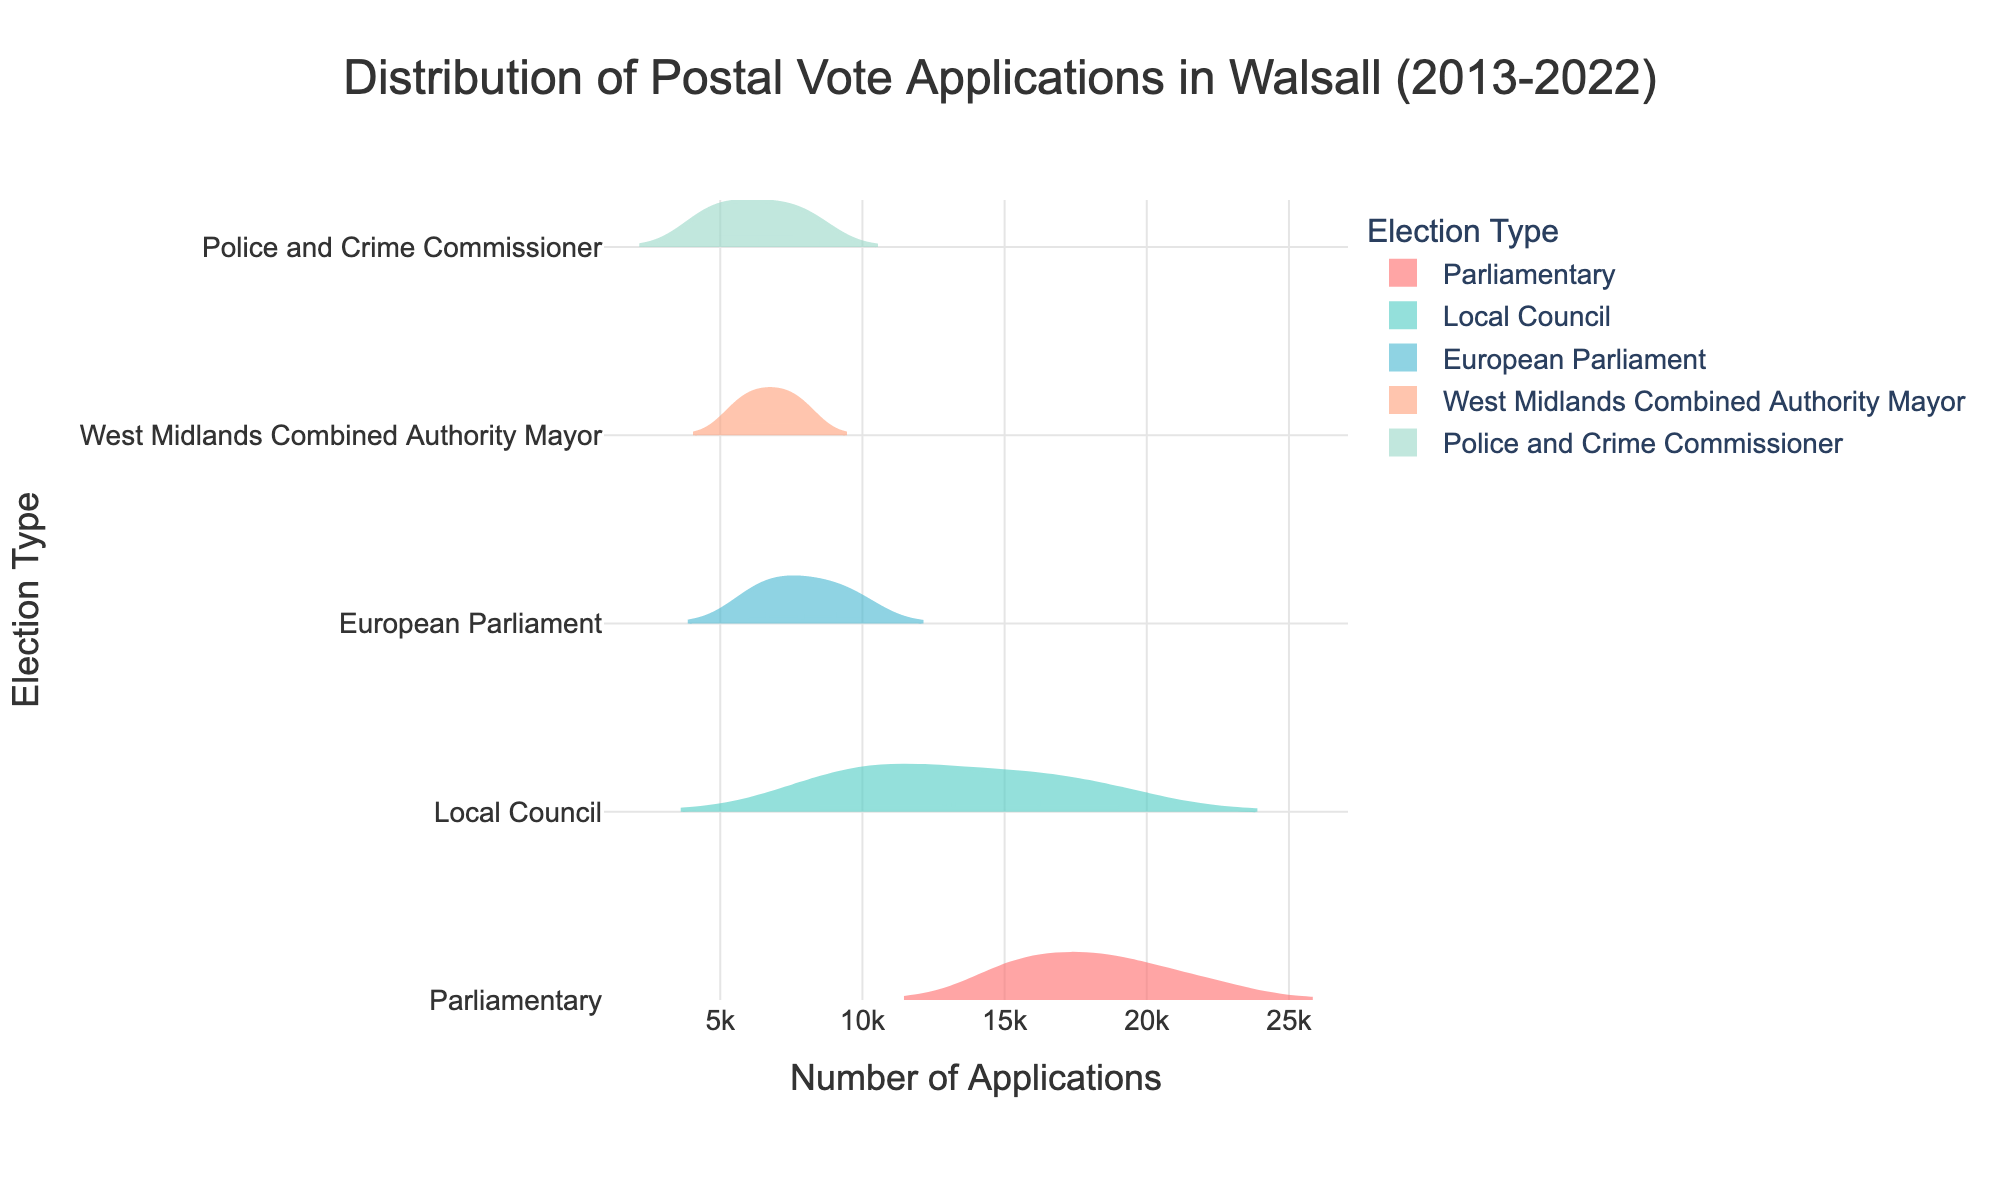What is the title of the plot? By looking at the top center of the figure, one can see the text describing the plot's purpose. It reads "Distribution of Postal Vote Applications in Walsall (2013-2022)"
Answer: Distribution of Postal Vote Applications in Walsall (2013-2022) Which election type has the highest median number of applications? The plot shows median values using a mean line within the density plot for each election type. The Parliamentary elections have the highest median number of applications as it stretches furthest to the right on the x-axis in comparison to other election types.
Answer: Parliamentary What is the mean number of applications for Local Council elections? In the plot, a mean line within the density plot indicates the mean number. For Local Council elections, it visually aligns around 13000-14000 on the x-axis. The exact visual inspection indicates a mean of about 12750.
Answer: 12750 How does the distribution of postal vote applications for Police and Crime Commissioner elections compare to that of Parliamentary elections? Parliamentary elections show a broader and higher density distribution, indicating a higher number of applications as compared to Police and Crime Commissioner elections, which have a narrower range and lower density.
Answer: Broader and higher for Parliamentary What's the range of postal vote applications for the European Parliament elections? The distribution for European Parliament elections spans between approximately 6000 and 10000 applications, as visually identifiable by the spread of the density plot on the x-axis.
Answer: 6000-10000 In which year did the West Midlands Combined Authority Mayor elections start seeing postal vote applications, and what was the approximate number? The density plot for the West Midlands Combined Authority Mayor elections appears from the year 2017 onwards, visibly seen extending from around 5500 applications on the x-axis.
Answer: 2017 and 5500 Which election type shows no data for the last three years in the dataset? The European Parliament elections' density plot is truncated and does not show any distribution for the last three years. The x-axis correspondingly lacks data points for 2020, 2021, and 2022.
Answer: European Parliament How do the range and density of applications for Local Council elections change over time? Observing the density plot for Local Council elections, the density increases and extends further right on the x-axis, indicating both an increase in the number of applications and a spread over a larger number of years.
Answer: Increasing density and range Which election type, aside from Parliamentary elections, has shown a consistent increase in the number of postal vote applications? Both Local Council and Police and Crime Commissioner elections exhibit a trend of increasing postal vote applications over time, seen by the densities moving consistently rightward over successive years.
Answer: Local Council and Police and Crime Commissioner 